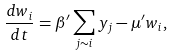Convert formula to latex. <formula><loc_0><loc_0><loc_500><loc_500>\frac { d w _ { i } } { d t } = \beta ^ { \prime } \sum _ { j \sim i } y _ { j } - \mu ^ { \prime } w _ { i } ,</formula> 